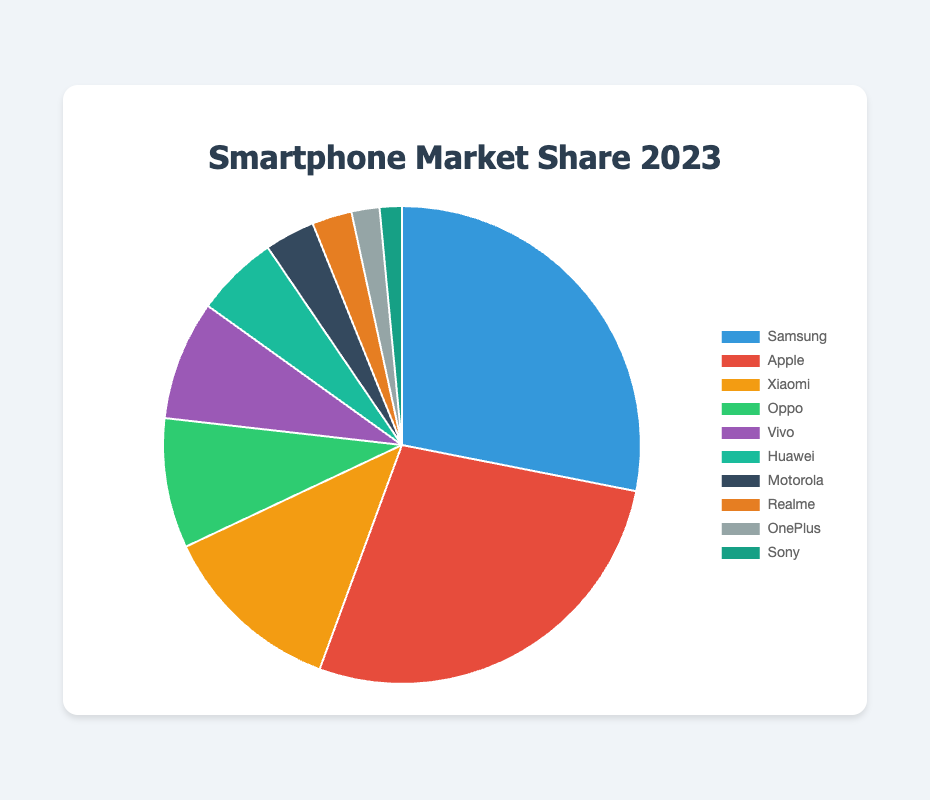Which smartphone brand holds the largest market share in 2023? By examining the pie chart, the sector with the largest size will represent the brand with the largest market share. Samsung has the largest sector.
Answer: Samsung What is the combined market share of Xiaomi, Oppo, and Vivo? To find the total market share for Xiaomi, Oppo, and Vivo, sum their individual market shares: 12.4 + 8.8 + 8.1 = 29.3%
Answer: 29.3% How much larger is Samsung's market share compared to Sony's market share? Calculate the difference between Samsung's and Sony's market shares: 28.1 - 1.5 = 26.6%
Answer: 26.6% What is the average market share of Apple, Huawei, and Motorola? Sum the market shares of Apple, Huawei, and Motorola, then divide by 3: (27.5 + 5.6 + 3.4) ÷ 3 = 12.1667%
Answer: 12.17% How many brands have a market share above 10%? By inspecting the pie chart, identify the sectors with market shares above 10%. Samsung, Apple, and Xiaomi each have market shares above 10%.
Answer: 3 Which brand has a market share closest to 5%? By examining the pie chart, identify the sector closest to 5% in size. Huawei has a market share of 5.6%, which is closest to 5%.
Answer: Huawei Rank the brands with market share between 2% and 5% from highest to lowest. Look at the pie chart and identify the brands with market shares between 2% and 5%, then sort them: Motorola (3.4%), Realme (2.7%), OnePlus (1.9%), Sony (1.5%).
Answer: Motorola, Realme, OnePlus, Sony What are the total market shares of all brands except Samsung and Apple? Subtract the market shares of Samsung and Apple from the total market (100%). Total of other brands: 100% - (28.1 + 27.5) = 44.4%
Answer: 44.4% Which smartphone brand has the green-colored section in the pie chart? Identify the sector with the green color in the pie chart, which Photoshop assigns to Oppo.
Answer: Oppo 